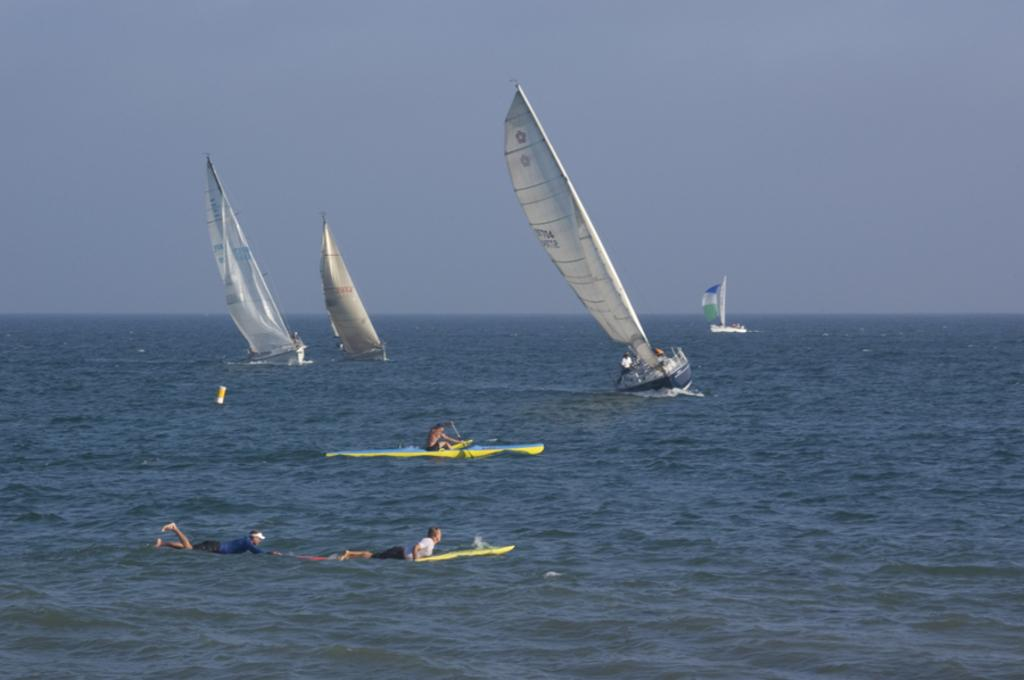What are the people in the image doing? The people in the image are surfing on surfboards. What objects are being used by the people while surfing? The surfboards are visible in the image. What else can be seen in the sea besides the people surfing? There are small ships in the sea. What is visible at the top of the image? The sky is visible at the top of the image. What type of street can be seen in the image? There is no street present in the image; it features people surfing on surfboards in the sea. What kind of apparel are the people wearing while surfing? The image does not provide enough detail to determine the specific apparel worn by the surfers. 